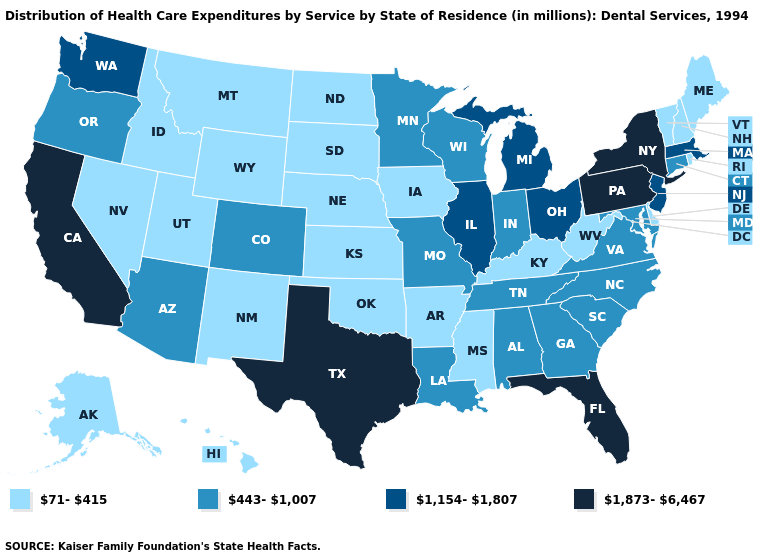Does Virginia have a lower value than Indiana?
Short answer required. No. Name the states that have a value in the range 71-415?
Answer briefly. Alaska, Arkansas, Delaware, Hawaii, Idaho, Iowa, Kansas, Kentucky, Maine, Mississippi, Montana, Nebraska, Nevada, New Hampshire, New Mexico, North Dakota, Oklahoma, Rhode Island, South Dakota, Utah, Vermont, West Virginia, Wyoming. Among the states that border New Mexico , does Utah have the lowest value?
Quick response, please. Yes. What is the value of Washington?
Answer briefly. 1,154-1,807. Does New Jersey have the lowest value in the Northeast?
Concise answer only. No. What is the value of Vermont?
Write a very short answer. 71-415. Among the states that border Kansas , does Oklahoma have the highest value?
Give a very brief answer. No. Among the states that border South Dakota , does Montana have the highest value?
Be succinct. No. Among the states that border Connecticut , which have the lowest value?
Keep it brief. Rhode Island. How many symbols are there in the legend?
Short answer required. 4. Among the states that border California , does Oregon have the lowest value?
Give a very brief answer. No. What is the value of Minnesota?
Answer briefly. 443-1,007. Which states have the lowest value in the West?
Quick response, please. Alaska, Hawaii, Idaho, Montana, Nevada, New Mexico, Utah, Wyoming. What is the value of Vermont?
Answer briefly. 71-415. Does Arizona have the highest value in the West?
Keep it brief. No. 